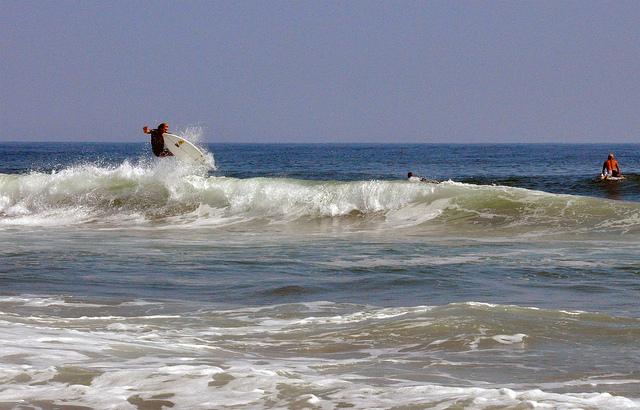How many people are in the water?
Be succinct. 2. How deep is the water?
Be succinct. Few feet. What is the man doing?
Write a very short answer. Surfing. 